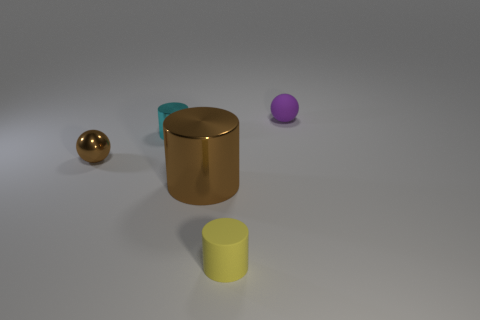Subtract all tiny cylinders. How many cylinders are left? 1 Subtract all cyan cylinders. How many cylinders are left? 2 Subtract all green rubber blocks. Subtract all cylinders. How many objects are left? 2 Add 3 purple balls. How many purple balls are left? 4 Add 2 purple metallic cylinders. How many purple metallic cylinders exist? 2 Add 4 metallic things. How many objects exist? 9 Subtract 1 cyan cylinders. How many objects are left? 4 Subtract all cylinders. How many objects are left? 2 Subtract all purple cylinders. Subtract all brown spheres. How many cylinders are left? 3 Subtract all blue cubes. How many green cylinders are left? 0 